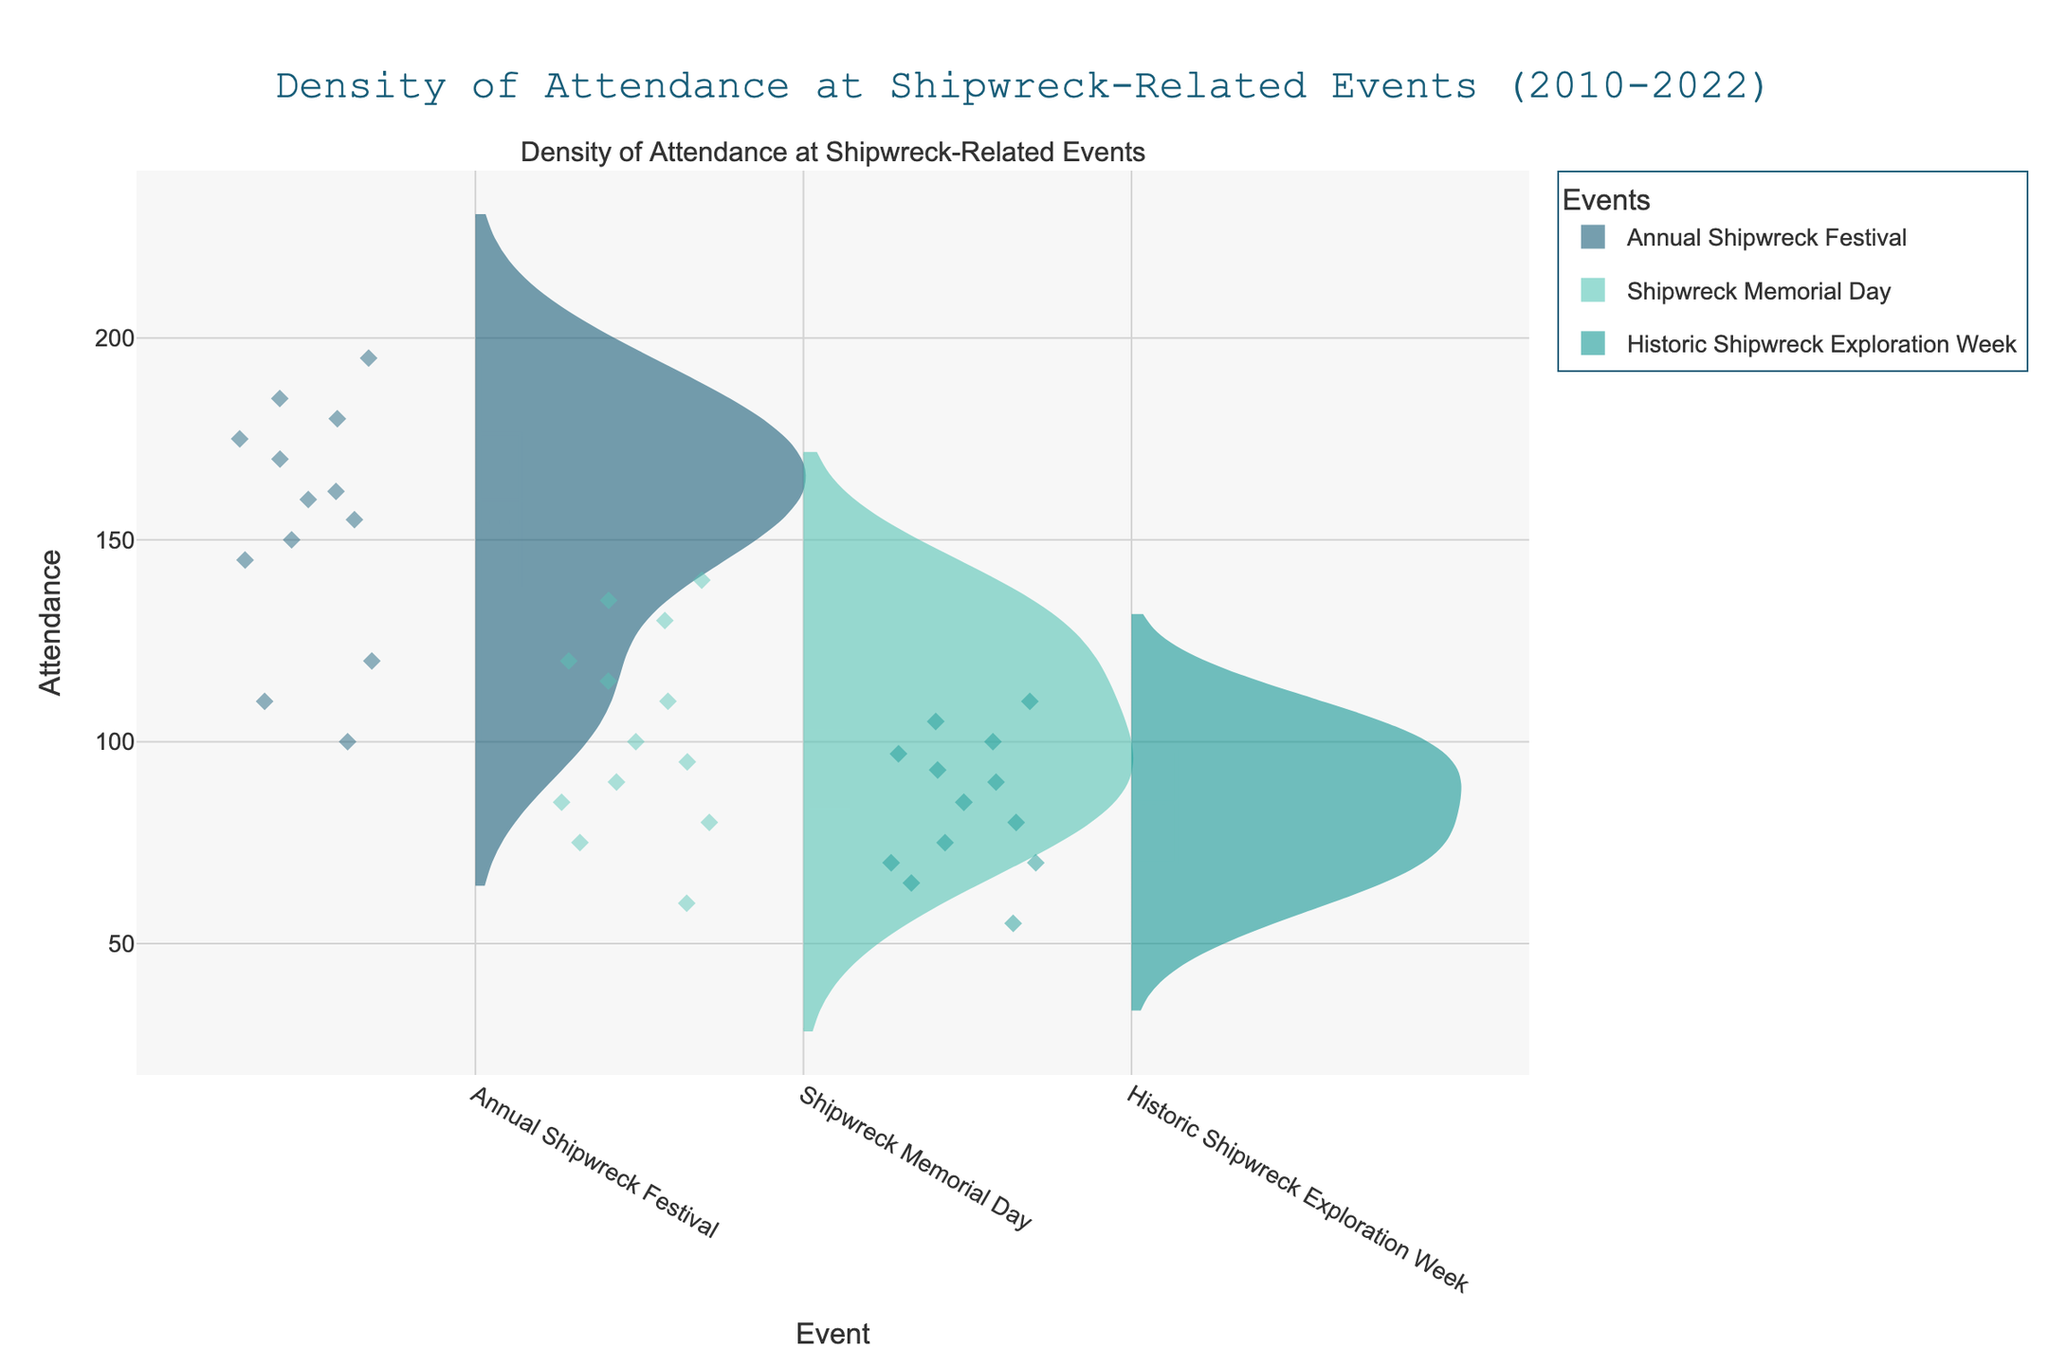What is the title of the plot? The title is located at the top center of the plot. It helps to understand what the plot is about. In this case, the title reads "Density of Attendance at Shipwreck-Related Events (2010-2022)."
Answer: Density of Attendance at Shipwreck-Related Events (2010-2022) How many events are represented in the plot? The x-axis shows categories labeled with the names of the events. By counting these labels, we can determine the number of different events.
Answer: 3 Which event has the highest average attendance? To find the event with the highest average attendance, look for the Violin plot that stretches the farthest upwards on the y-axis since it indicates higher attendance figures. Compare the positions of the mean lines of the different events.
Answer: Annual Shipwreck Festival What trend in attendance is observed around 2020 for all events? Identify the individual dots (attendance data points) and notice the dip around the year 2020 across all events. This indicates a significant drop in attendance during that period.
Answer: Decrease in attendance Which event has the smallest variance in attendance over the years? Variance can be inferred from the width and shape of the Violin plots. Narrower plots indicate less variance. Compare the widths across the events.
Answer: Shipwreck Memorial Day Compare the highest attendance between "Annual Shipwreck Festival" and "Historic Shipwreck Exploration Week." Which one is higher? Look at the topmost data points within each event's Violin plot. Compare the y-axis values at these points.
Answer: Annual Shipwreck Festival What might explain the drop in attendance around 2020? This question requires reasoning beyond the plot. Consider historical events around 2020 that could impact community gatherings, such as the global COVID-19 pandemic. Many events experienced reduced attendance due to restrictions and safety concerns.
Answer: COVID-19 pandemic Which event shows a steady increase in attendance until 2019? Observe the trajectory of dots within each event's Violin plot. The event with dots consistently moving upward each year until 2019 shows a steady increase.
Answer: Annual Shipwreck Festival Between "Shipwreck Memorial Day" and "Historic Shipwreck Exploration Week," which event recovered better after 2020? Compare the upward trend of attendance dots after 2020 for both events. The one that shows a more significant recovery in terms of increased attendance post-2020 has recovered better.
Answer: Shipwreck Memorial Day What visual elements help indicate the distribution of data points for each event? Look at elements like the shape of the violin plot, the individual data points shown as diamonds, and the mean lines. These visual cues provide insights into the distribution, spread, and central tendency of the attendance data.
Answer: Violin plot shape, data points, mean lines 